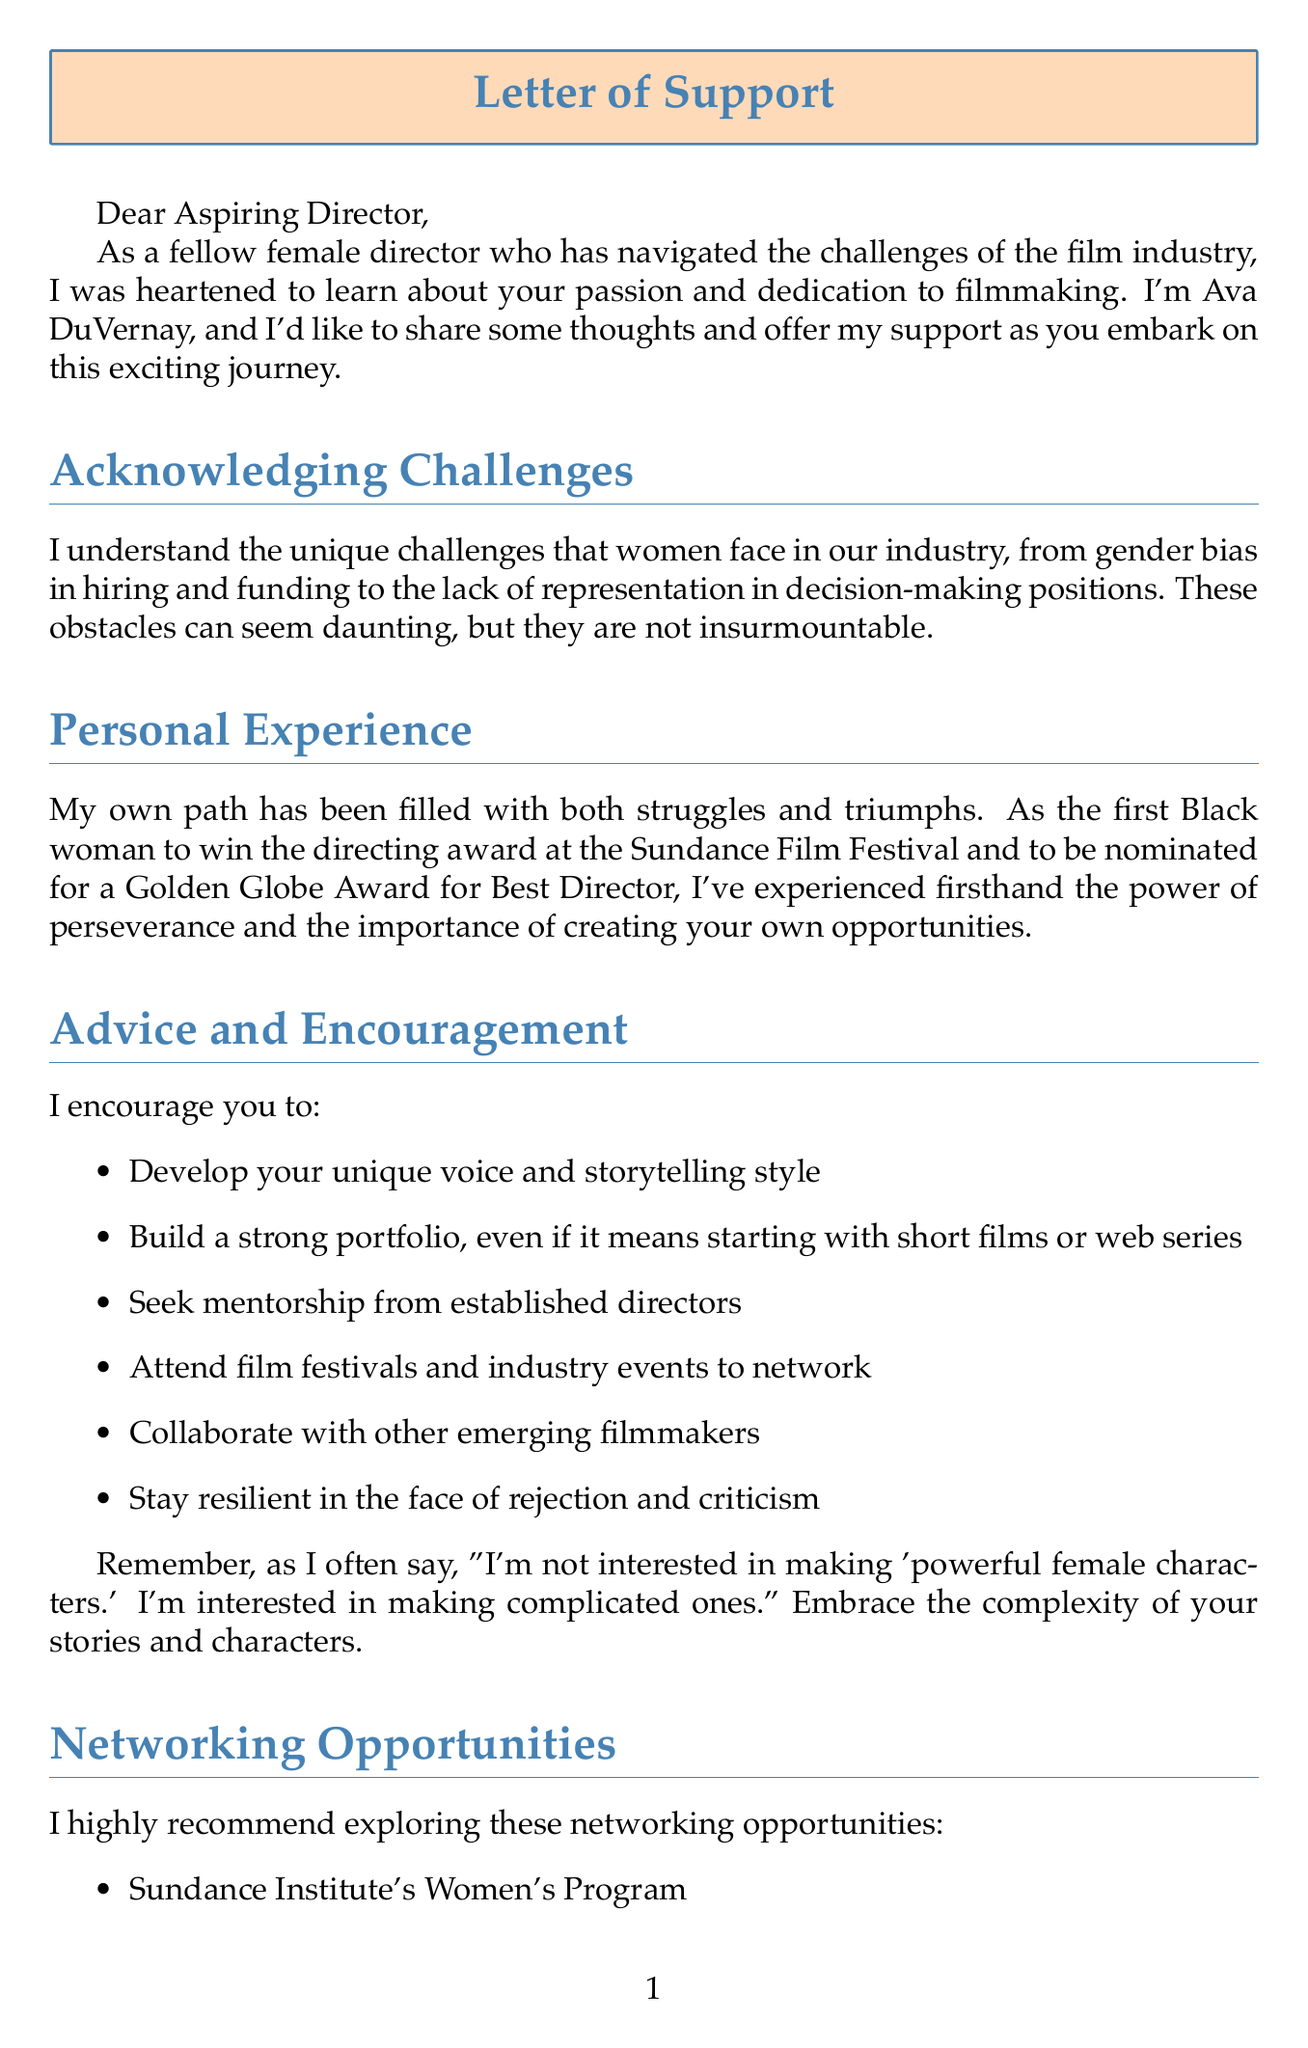What is the name of the successful director? The document introduces the successful director as Ava DuVernay.
Answer: Ava DuVernay What notable award did Ava DuVernay receive at the Sundance Film Festival? The document states that she is the first Black woman to win the directing award at the Sundance Film Festival.
Answer: Directing award What type of program does the Sundance Institute's Women's Program offer? The section on networking opportunities mentions that it offers mentorship, funding, and networking opportunities.
Answer: Mentorship Name one challenge women face in the film industry according to the document. The document lists several challenges; one is gender bias in hiring and funding.
Answer: Gender bias What quote is attributed to Greta Gerwig in the document? The document includes a quote from Greta Gerwig about making complicated characters.
Answer: "I'm not interested in making 'powerful female characters.' I'm interested in making complicated ones." What initiative supports women at the Toronto International Film Festival? The document refers to "Share Her Journey" as the initiative supporting women at TIFF.
Answer: Share Her Journey How does Ava DuVernay offer to support aspiring directors? The document states that she would be happy to review their work and provide feedback.
Answer: Review work What organization is focused on supporting women producers and directors? The document mentions "Women Make Movies" as a supportive organization for women in the industry.
Answer: Women Make Movies 